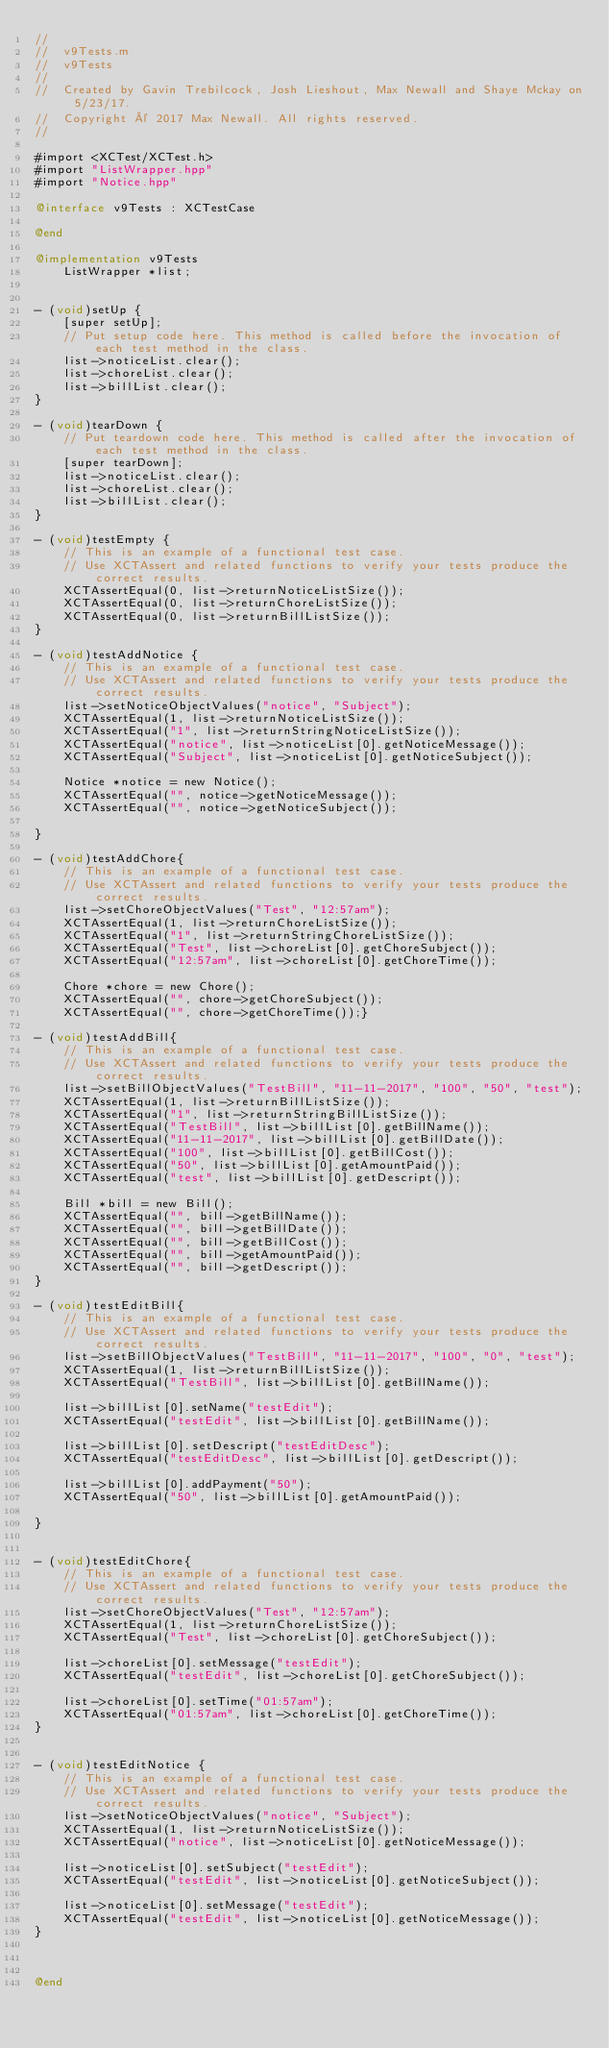<code> <loc_0><loc_0><loc_500><loc_500><_ObjectiveC_>//
//  v9Tests.m
//  v9Tests
//
//  Created by Gavin Trebilcock, Josh Lieshout, Max Newall and Shaye Mckay on 5/23/17.
//  Copyright © 2017 Max Newall. All rights reserved.
//

#import <XCTest/XCTest.h>
#import "ListWrapper.hpp"
#import "Notice.hpp"

@interface v9Tests : XCTestCase

@end

@implementation v9Tests
    ListWrapper *list;


- (void)setUp {
    [super setUp];
    // Put setup code here. This method is called before the invocation of each test method in the class.
    list->noticeList.clear();
    list->choreList.clear();
    list->billList.clear();
}

- (void)tearDown {
    // Put teardown code here. This method is called after the invocation of each test method in the class.
    [super tearDown];
    list->noticeList.clear();
    list->choreList.clear();
    list->billList.clear();
}

- (void)testEmpty {
    // This is an example of a functional test case.
    // Use XCTAssert and related functions to verify your tests produce the correct results.
    XCTAssertEqual(0, list->returnNoticeListSize());
    XCTAssertEqual(0, list->returnChoreListSize());
    XCTAssertEqual(0, list->returnBillListSize());
}

- (void)testAddNotice {
    // This is an example of a functional test case.
    // Use XCTAssert and related functions to verify your tests produce the correct results.
    list->setNoticeObjectValues("notice", "Subject");
    XCTAssertEqual(1, list->returnNoticeListSize());
    XCTAssertEqual("1", list->returnStringNoticeListSize());
    XCTAssertEqual("notice", list->noticeList[0].getNoticeMessage());
    XCTAssertEqual("Subject", list->noticeList[0].getNoticeSubject());
    
    Notice *notice = new Notice();
    XCTAssertEqual("", notice->getNoticeMessage());
    XCTAssertEqual("", notice->getNoticeSubject());
    
}

- (void)testAddChore{
    // This is an example of a functional test case.
    // Use XCTAssert and related functions to verify your tests produce the correct results.
    list->setChoreObjectValues("Test", "12:57am");
    XCTAssertEqual(1, list->returnChoreListSize());
    XCTAssertEqual("1", list->returnStringChoreListSize());
    XCTAssertEqual("Test", list->choreList[0].getChoreSubject());
    XCTAssertEqual("12:57am", list->choreList[0].getChoreTime());
    
    Chore *chore = new Chore();
    XCTAssertEqual("", chore->getChoreSubject());
    XCTAssertEqual("", chore->getChoreTime());}

- (void)testAddBill{
    // This is an example of a functional test case.
    // Use XCTAssert and related functions to verify your tests produce the correct results.
    list->setBillObjectValues("TestBill", "11-11-2017", "100", "50", "test");
    XCTAssertEqual(1, list->returnBillListSize());
    XCTAssertEqual("1", list->returnStringBillListSize());
    XCTAssertEqual("TestBill", list->billList[0].getBillName());
    XCTAssertEqual("11-11-2017", list->billList[0].getBillDate());
    XCTAssertEqual("100", list->billList[0].getBillCost());
    XCTAssertEqual("50", list->billList[0].getAmountPaid());
    XCTAssertEqual("test", list->billList[0].getDescript());
    
    Bill *bill = new Bill();
    XCTAssertEqual("", bill->getBillName());
    XCTAssertEqual("", bill->getBillDate());
    XCTAssertEqual("", bill->getBillCost());
    XCTAssertEqual("", bill->getAmountPaid());
    XCTAssertEqual("", bill->getDescript());
}

- (void)testEditBill{
    // This is an example of a functional test case.
    // Use XCTAssert and related functions to verify your tests produce the correct results.
    list->setBillObjectValues("TestBill", "11-11-2017", "100", "0", "test");
    XCTAssertEqual(1, list->returnBillListSize());
    XCTAssertEqual("TestBill", list->billList[0].getBillName());
    
    list->billList[0].setName("testEdit");
    XCTAssertEqual("testEdit", list->billList[0].getBillName());
    
    list->billList[0].setDescript("testEditDesc");
    XCTAssertEqual("testEditDesc", list->billList[0].getDescript());
    
    list->billList[0].addPayment("50");
    XCTAssertEqual("50", list->billList[0].getAmountPaid());

}


- (void)testEditChore{
    // This is an example of a functional test case.
    // Use XCTAssert and related functions to verify your tests produce the correct results.
    list->setChoreObjectValues("Test", "12:57am");
    XCTAssertEqual(1, list->returnChoreListSize());
    XCTAssertEqual("Test", list->choreList[0].getChoreSubject());
    
    list->choreList[0].setMessage("testEdit");
    XCTAssertEqual("testEdit", list->choreList[0].getChoreSubject());
    
    list->choreList[0].setTime("01:57am");
    XCTAssertEqual("01:57am", list->choreList[0].getChoreTime());
}


- (void)testEditNotice {
    // This is an example of a functional test case.
    // Use XCTAssert and related functions to verify your tests produce the correct results.
    list->setNoticeObjectValues("notice", "Subject");
    XCTAssertEqual(1, list->returnNoticeListSize());
    XCTAssertEqual("notice", list->noticeList[0].getNoticeMessage());
    
    list->noticeList[0].setSubject("testEdit");
    XCTAssertEqual("testEdit", list->noticeList[0].getNoticeSubject());
    
    list->noticeList[0].setMessage("testEdit");
    XCTAssertEqual("testEdit", list->noticeList[0].getNoticeMessage());
}



@end
</code> 